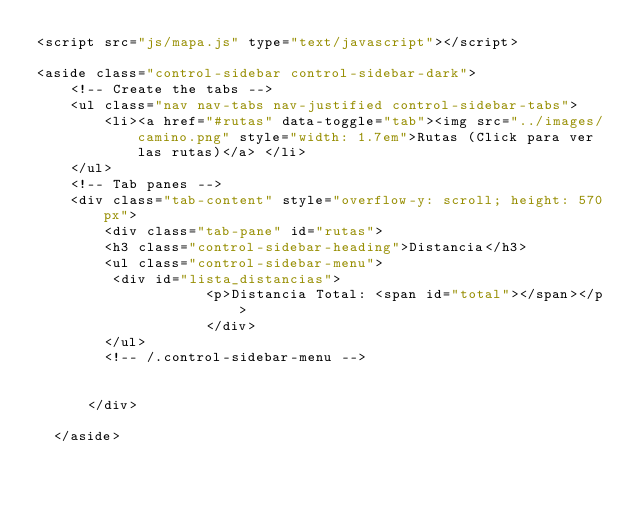<code> <loc_0><loc_0><loc_500><loc_500><_PHP_><script src="js/mapa.js" type="text/javascript"></script>  

<aside class="control-sidebar control-sidebar-dark">
    <!-- Create the tabs -->
    <ul class="nav nav-tabs nav-justified control-sidebar-tabs">
        <li><a href="#rutas" data-toggle="tab"><img src="../images/camino.png" style="width: 1.7em">Rutas (Click para ver las rutas)</a> </li>      
    </ul>
    <!-- Tab panes -->
    <div class="tab-content" style="overflow-y: scroll; height: 570px">
        <div class="tab-pane" id="rutas">
        <h3 class="control-sidebar-heading">Distancia</h3>
        <ul class="control-sidebar-menu">
         <div id="lista_distancias">
                    <p>Distancia Total: <span id="total"></span></p>
                    </div>
        </ul>
        <!-- /.control-sidebar-menu -->


      </div>
     
  </aside></code> 